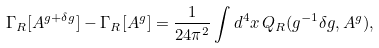<formula> <loc_0><loc_0><loc_500><loc_500>\Gamma _ { R } [ A ^ { g + \delta g } ] - \Gamma _ { R } [ A ^ { g } ] = \frac { 1 } { 2 4 \pi ^ { 2 } } \int d ^ { 4 } x \, Q _ { R } ( g ^ { - 1 } \delta g , A ^ { g } ) ,</formula> 